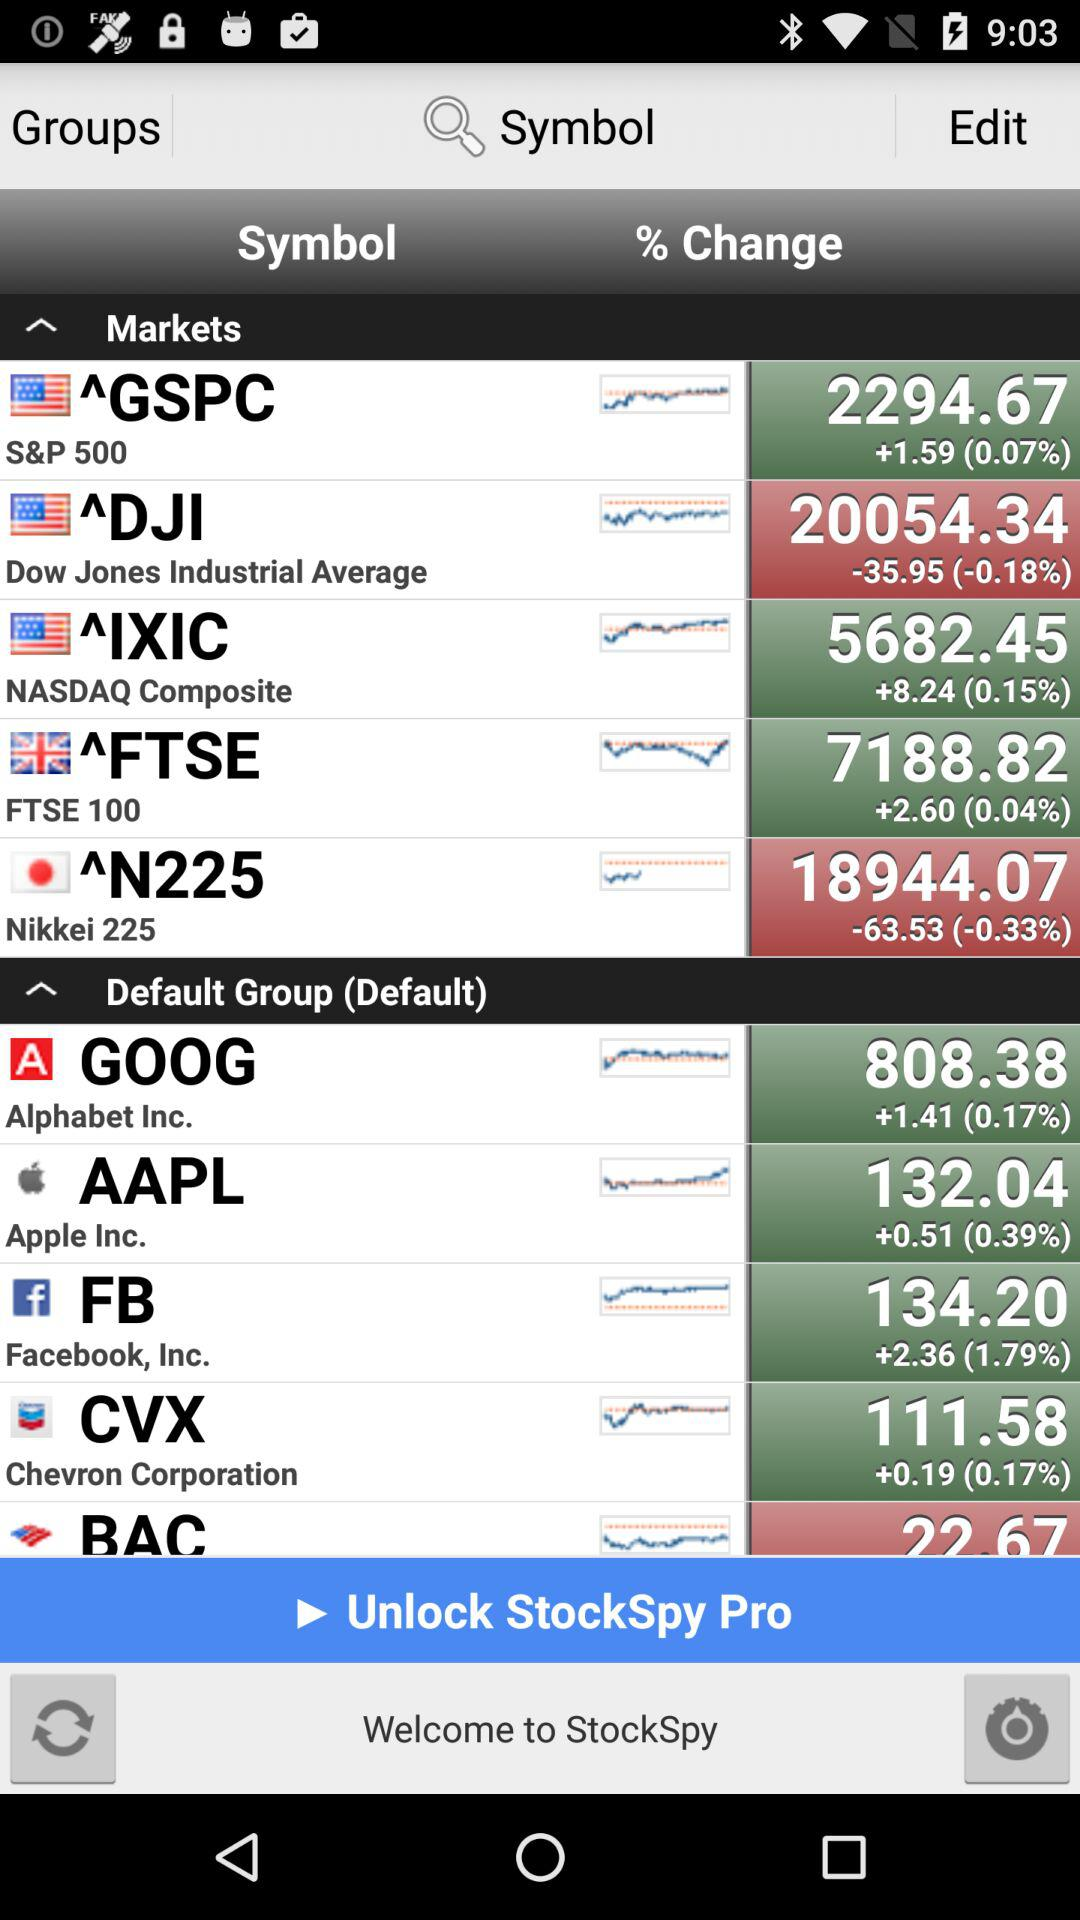What is the market value of Apple Inc.? The market value is 132.04. 